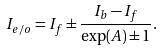Convert formula to latex. <formula><loc_0><loc_0><loc_500><loc_500>I _ { e / o } = I _ { f } \pm \frac { I _ { b } - I _ { f } } { \exp ( A ) \pm 1 } .</formula> 